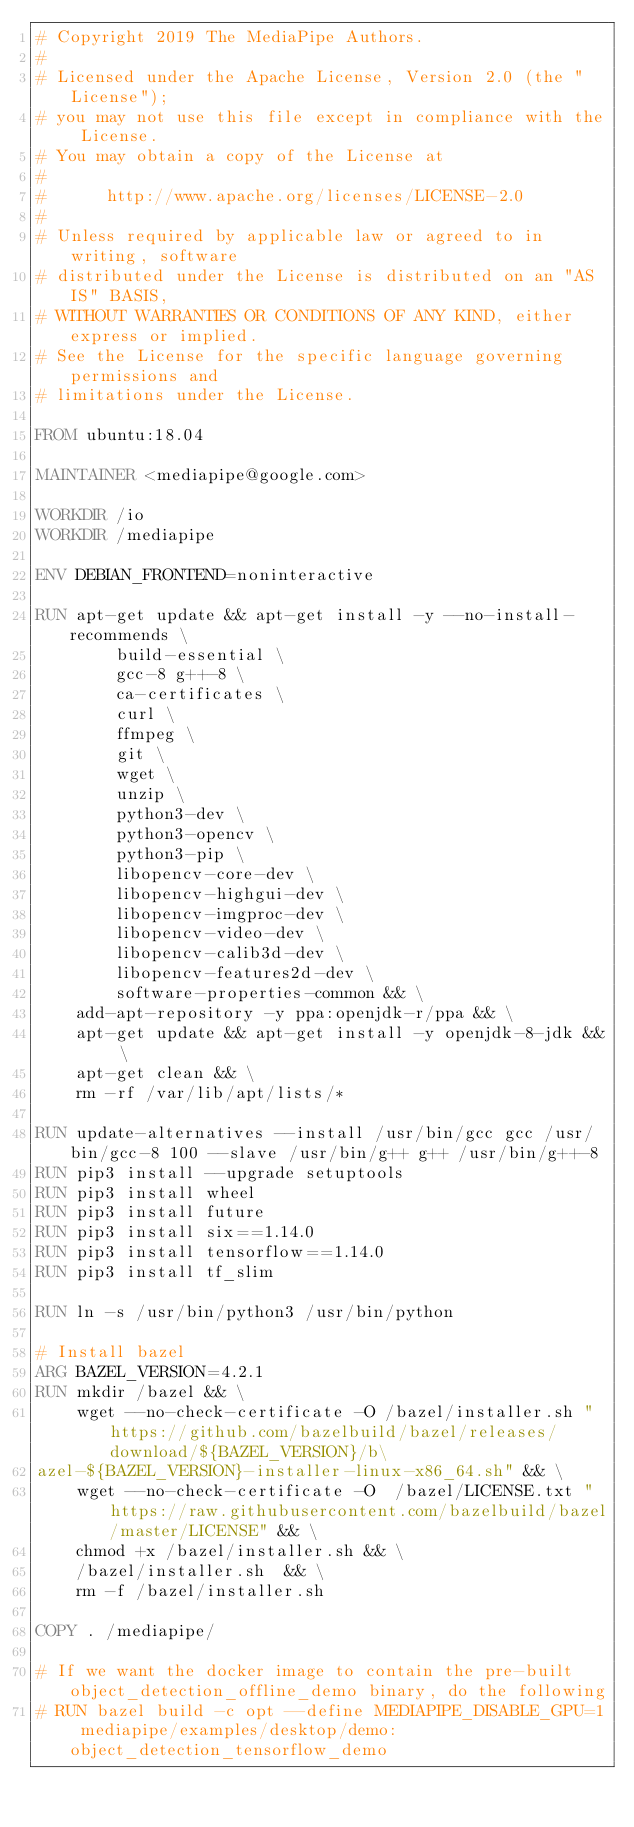<code> <loc_0><loc_0><loc_500><loc_500><_Dockerfile_># Copyright 2019 The MediaPipe Authors.
#
# Licensed under the Apache License, Version 2.0 (the "License");
# you may not use this file except in compliance with the License.
# You may obtain a copy of the License at
#
#      http://www.apache.org/licenses/LICENSE-2.0
#
# Unless required by applicable law or agreed to in writing, software
# distributed under the License is distributed on an "AS IS" BASIS,
# WITHOUT WARRANTIES OR CONDITIONS OF ANY KIND, either express or implied.
# See the License for the specific language governing permissions and
# limitations under the License.

FROM ubuntu:18.04

MAINTAINER <mediapipe@google.com>

WORKDIR /io
WORKDIR /mediapipe

ENV DEBIAN_FRONTEND=noninteractive

RUN apt-get update && apt-get install -y --no-install-recommends \
        build-essential \
        gcc-8 g++-8 \
        ca-certificates \
        curl \
        ffmpeg \
        git \
        wget \
        unzip \
        python3-dev \
        python3-opencv \
        python3-pip \
        libopencv-core-dev \
        libopencv-highgui-dev \
        libopencv-imgproc-dev \
        libopencv-video-dev \
        libopencv-calib3d-dev \
        libopencv-features2d-dev \
        software-properties-common && \
    add-apt-repository -y ppa:openjdk-r/ppa && \
    apt-get update && apt-get install -y openjdk-8-jdk && \
    apt-get clean && \
    rm -rf /var/lib/apt/lists/*

RUN update-alternatives --install /usr/bin/gcc gcc /usr/bin/gcc-8 100 --slave /usr/bin/g++ g++ /usr/bin/g++-8
RUN pip3 install --upgrade setuptools
RUN pip3 install wheel
RUN pip3 install future
RUN pip3 install six==1.14.0
RUN pip3 install tensorflow==1.14.0
RUN pip3 install tf_slim

RUN ln -s /usr/bin/python3 /usr/bin/python

# Install bazel
ARG BAZEL_VERSION=4.2.1
RUN mkdir /bazel && \
    wget --no-check-certificate -O /bazel/installer.sh "https://github.com/bazelbuild/bazel/releases/download/${BAZEL_VERSION}/b\
azel-${BAZEL_VERSION}-installer-linux-x86_64.sh" && \
    wget --no-check-certificate -O  /bazel/LICENSE.txt "https://raw.githubusercontent.com/bazelbuild/bazel/master/LICENSE" && \
    chmod +x /bazel/installer.sh && \
    /bazel/installer.sh  && \
    rm -f /bazel/installer.sh

COPY . /mediapipe/

# If we want the docker image to contain the pre-built object_detection_offline_demo binary, do the following
# RUN bazel build -c opt --define MEDIAPIPE_DISABLE_GPU=1 mediapipe/examples/desktop/demo:object_detection_tensorflow_demo
</code> 